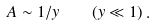Convert formula to latex. <formula><loc_0><loc_0><loc_500><loc_500>A \sim 1 / y \quad ( y \ll 1 ) \, .</formula> 